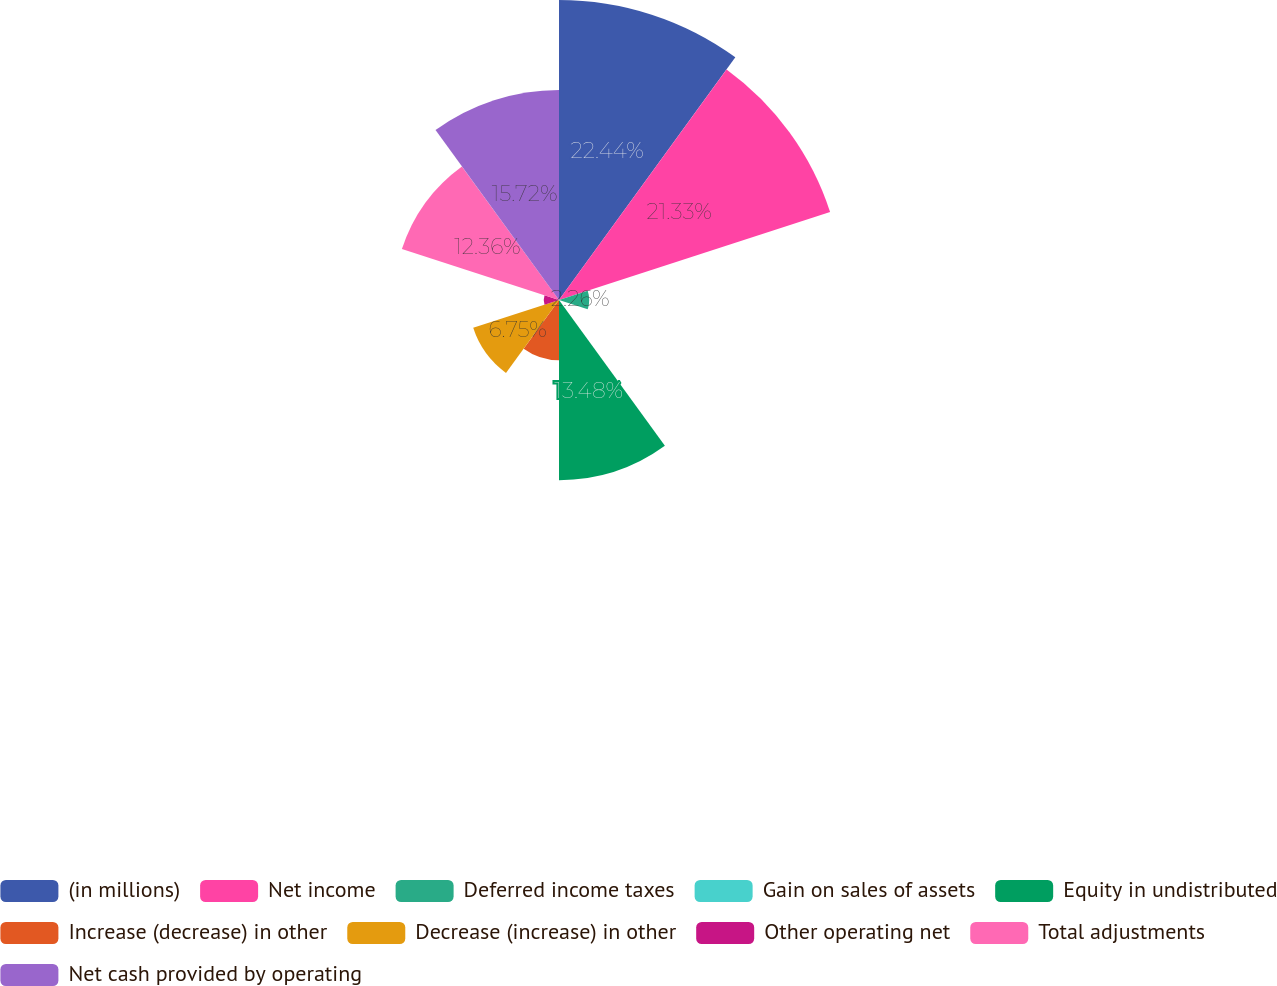Convert chart. <chart><loc_0><loc_0><loc_500><loc_500><pie_chart><fcel>(in millions)<fcel>Net income<fcel>Deferred income taxes<fcel>Gain on sales of assets<fcel>Equity in undistributed<fcel>Increase (decrease) in other<fcel>Decrease (increase) in other<fcel>Other operating net<fcel>Total adjustments<fcel>Net cash provided by operating<nl><fcel>22.45%<fcel>21.33%<fcel>2.26%<fcel>0.02%<fcel>13.48%<fcel>4.5%<fcel>6.75%<fcel>1.14%<fcel>12.36%<fcel>15.72%<nl></chart> 